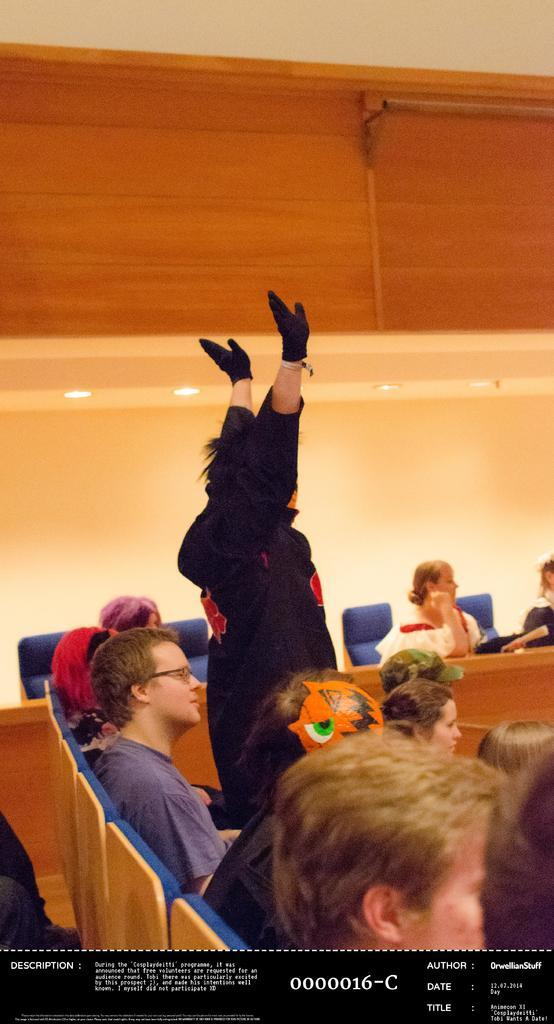What are the people in the image doing? The people in the image are sitting. Is there anyone standing in the image? Yes, one person is standing in the image. What can be seen in the background of the image? There is a wall in the background of the image. What is visible at the top of the image? There is a ceiling visible at the top of the image. Can you see an island in the image? No, there is no island present in the image. 